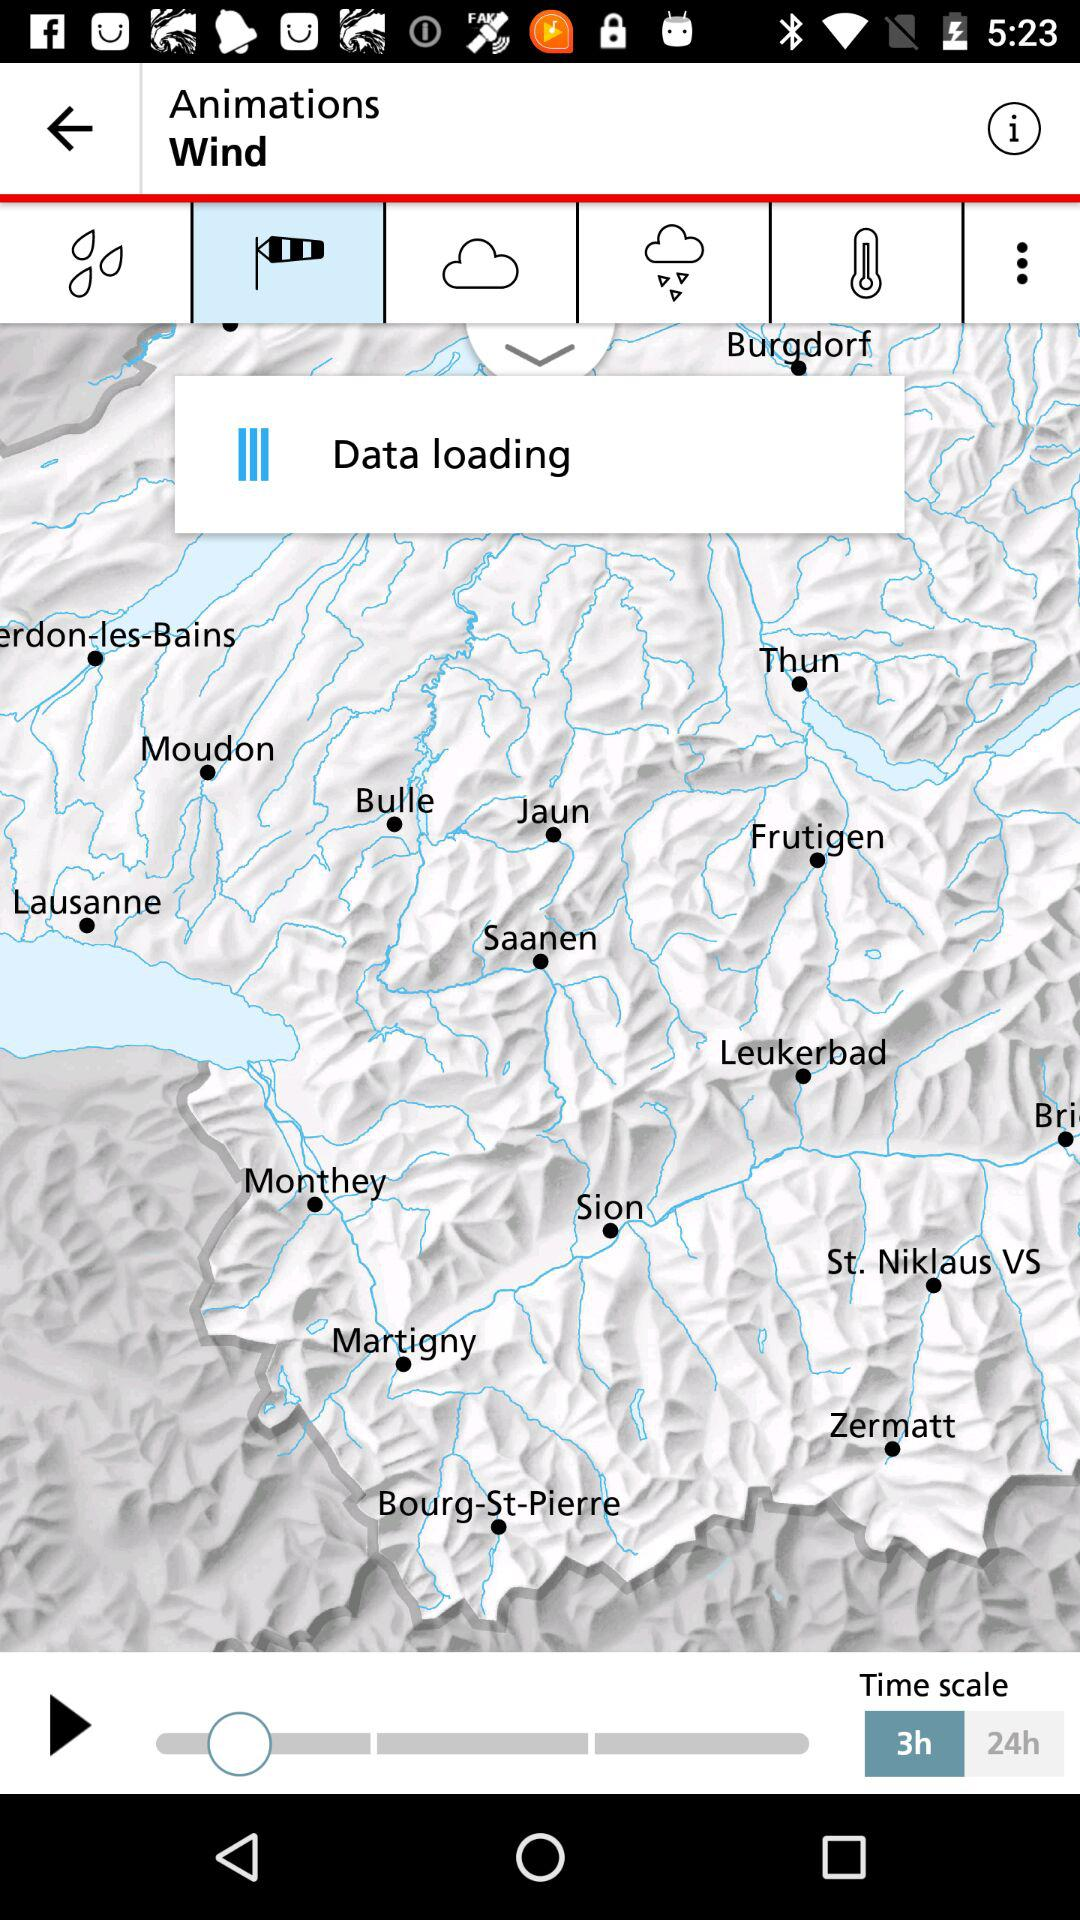Which animation effect is currently shown on the screen? The currently shown animation effect is "Wind". 